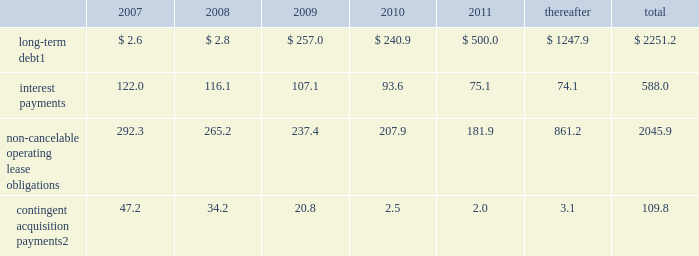Credit agency ratings our long-term debt credit ratings as of february 16 , 2007 were ba3 with negative outlook , b creditwatch negative and b with negative outlook , as reported by moody 2019s investors service , standard & poor 2019s and fitch ratings , respectively .
A downgrade in our credit ratings could adversely affect our ability to access capital and could result in more stringent covenants and higher interest rates under the terms of any new indebtedness .
Contractual obligations the following summarizes our estimated contractual obligations at december 31 , 2006 , and their effect on our liquidity and cash flow in future periods: .
Contingent acquisition payments 2 47.2 34.2 20.8 2.5 2.0 3.1 109.8 1 holders of our $ 400.0 4.50% ( 4.50 % ) notes may require us to repurchase their notes for cash at par in march 2008 .
These notes will mature in 2023 if not converted or repurchased .
2 we have structured certain acquisitions with additional contingent purchase price obligations in order to reduce the potential risk associated with negative future performance of the acquired entity .
All payments are contingent upon achieving projected operating performance targets and satisfying other conditions specified in the related agreements and are subject to revisions as the earn-out periods progress .
See note 18 to the consolidated financial statements for further information .
We have not included obligations under our pension and postretirement benefit plans in the contractual obligations table .
Our funding policy regarding our funded pension plan is to contribute amounts necessary to satisfy minimum pension funding requirements plus such additional amounts from time to time as are determined to be appropriate to improve the plans 2019 funded status .
The funded status of our pension plans is dependent upon many factors , including returns on invested assets , level of market interest rates and levels of voluntary contributions to the plans .
Declines in long-term interest rates have had a negative impact on the funded status of the plans .
For 2007 , we do not expect to contribute to our domestic pension plans , and expect to contribute $ 20.6 to our foreign pension plans .
We have not included our deferred tax obligations in the contractual obligations table as the timing of any future payments in relation to these obligations is uncertain .
Derivatives and hedging activities we periodically enter into interest rate swap agreements and forward contracts to manage exposure to interest rate fluctuations and to mitigate foreign exchange volatility .
In may of 2005 , we terminated all of our long-term interest rate swap agreements covering the $ 350.0 6.25% ( 6.25 % ) senior unsecured notes and $ 150.0 of the $ 500.0 7.25% ( 7.25 % ) senior unsecured notes .
In connection with the interest rate swap termination , our net cash receipts were $ 1.1 , which is recorded as an offset to interest expense over the remaining life of the related debt .
We have entered into foreign currency transactions in which various foreign currencies are bought or sold forward .
These contracts were entered into to meet currency requirements arising from specific transactions .
The changes in value of these forward contracts have been recorded in other income or expense .
As of december 31 , 2006 and 2005 , we had contracts covering $ 0.2 and $ 6.2 , respectively , of notional amount of currency and the fair value of the forward contracts was negligible .
The terms of the 4.50% ( 4.50 % ) notes include two embedded derivative instruments and the terms of our 4.25% ( 4.25 % ) notes and our series b preferred stock each include one embedded derivative instrument .
The fair value of these derivatives on december 31 , 2006 was negligible .
The interpublic group of companies , inc .
And subsidiaries management 2019s discussion and analysis of financial condition and results of operations 2014 ( continued ) ( amounts in millions , except per share amounts ) %%transmsg*** transmitting job : y31000 pcn : 036000000 ***%%pcmsg|36 |00005|yes|no|02/28/2007 01:12|0|0|page is valid , no graphics -- color : d| .
What portion of the total long-term debt should be included in the current liabilities section of the balance sheet as of december 31 , 2006? 
Computations: (2.6 / 2251.2)
Answer: 0.00115. 